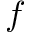<formula> <loc_0><loc_0><loc_500><loc_500>f</formula> 